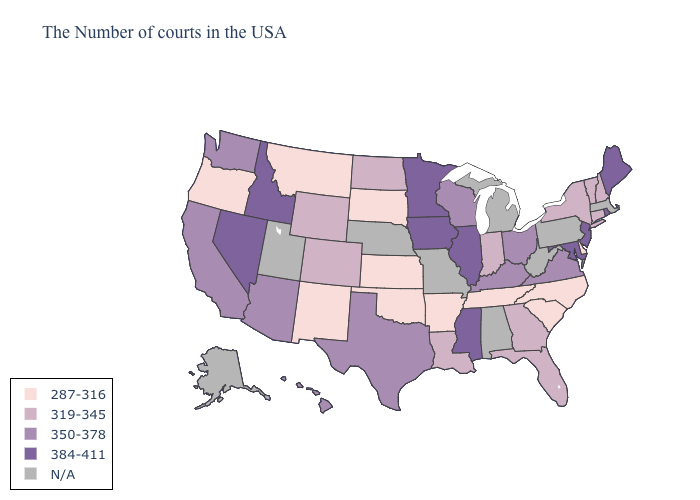Name the states that have a value in the range N/A?
Give a very brief answer. Massachusetts, Pennsylvania, West Virginia, Michigan, Alabama, Missouri, Nebraska, Utah, Alaska. Does Montana have the lowest value in the West?
Be succinct. Yes. Does Hawaii have the lowest value in the West?
Concise answer only. No. Name the states that have a value in the range 350-378?
Write a very short answer. Virginia, Ohio, Kentucky, Wisconsin, Texas, Arizona, California, Washington, Hawaii. What is the lowest value in states that border Ohio?
Concise answer only. 319-345. What is the value of Colorado?
Write a very short answer. 319-345. Does Rhode Island have the highest value in the Northeast?
Concise answer only. Yes. Name the states that have a value in the range 350-378?
Give a very brief answer. Virginia, Ohio, Kentucky, Wisconsin, Texas, Arizona, California, Washington, Hawaii. Name the states that have a value in the range 384-411?
Keep it brief. Maine, Rhode Island, New Jersey, Maryland, Illinois, Mississippi, Minnesota, Iowa, Idaho, Nevada. Name the states that have a value in the range N/A?
Keep it brief. Massachusetts, Pennsylvania, West Virginia, Michigan, Alabama, Missouri, Nebraska, Utah, Alaska. What is the highest value in the USA?
Short answer required. 384-411. Which states have the highest value in the USA?
Keep it brief. Maine, Rhode Island, New Jersey, Maryland, Illinois, Mississippi, Minnesota, Iowa, Idaho, Nevada. Name the states that have a value in the range N/A?
Answer briefly. Massachusetts, Pennsylvania, West Virginia, Michigan, Alabama, Missouri, Nebraska, Utah, Alaska. Among the states that border North Carolina , which have the highest value?
Quick response, please. Virginia. 